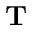Convert formula to latex. <formula><loc_0><loc_0><loc_500><loc_500>T</formula> 